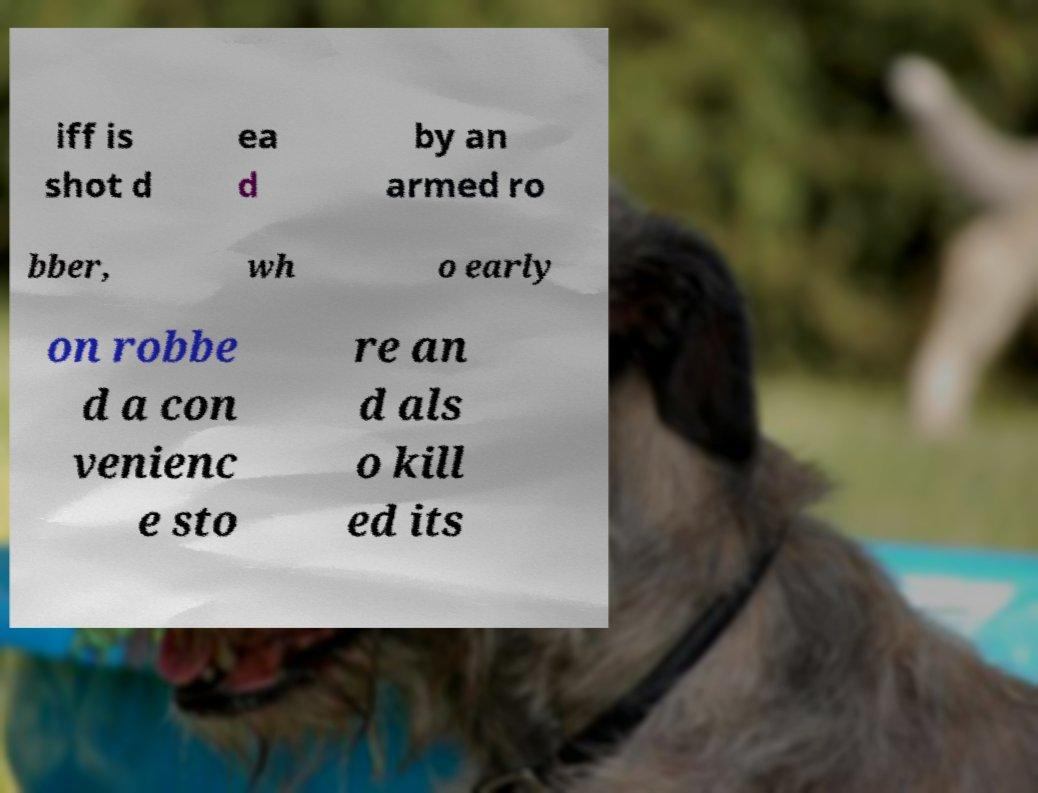Could you extract and type out the text from this image? iff is shot d ea d by an armed ro bber, wh o early on robbe d a con venienc e sto re an d als o kill ed its 